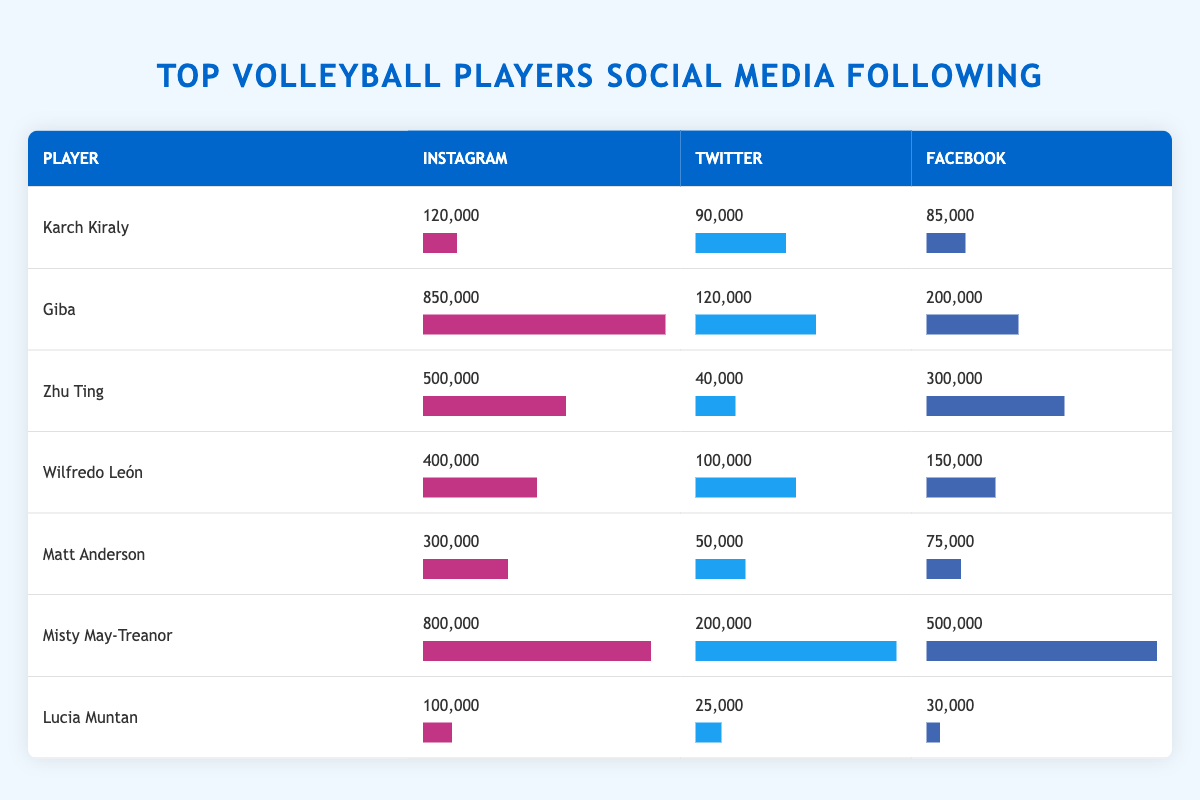What is the highest number of Instagram followers among the players listed? The player with the highest number of Instagram followers is Giba with 850,000 followers.
Answer: 850,000 Who has more followers on Facebook, Karch Kiraly or Wilfredo León? Karch Kiraly has 85,000 followers while Wilfredo León has 150,000 followers. Therefore, Wilfredo León has more Facebook followers.
Answer: Wilfredo León What is the total number of Twitter followers for all players combined? Adding the Twitter followers: 90,000 + 120,000 + 40,000 + 100,000 + 50,000 + 200,000 + 25,000 = 625,000 followers in total.
Answer: 625,000 Is Misty May-Treanor the only player with over 500,000 followers on any platform? Misty May-Treanor has over 500,000 followers on Facebook and Instagram, while Giba also has over 500,000 on Instagram. Therefore, she is not the only one.
Answer: No Which player has the most overall social media following across all platforms? First, we sum the followers on each platform for every player: Karch Kiraly (295,000), Giba (1,170,000), Zhu Ting (840,000), Wilfredo León (650,000), Matt Anderson (425,000), Misty May-Treanor (1,500,000), Lucia Muntan (155,000). The total for Misty May-Treanor is the highest at 1,500,000.
Answer: Misty May-Treanor 